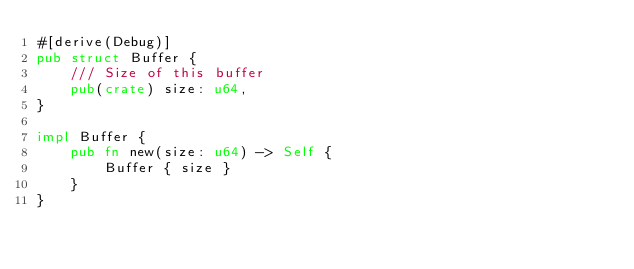<code> <loc_0><loc_0><loc_500><loc_500><_Rust_>#[derive(Debug)]
pub struct Buffer {
    /// Size of this buffer
    pub(crate) size: u64,
}

impl Buffer {
    pub fn new(size: u64) -> Self {
        Buffer { size }
    }
}
</code> 